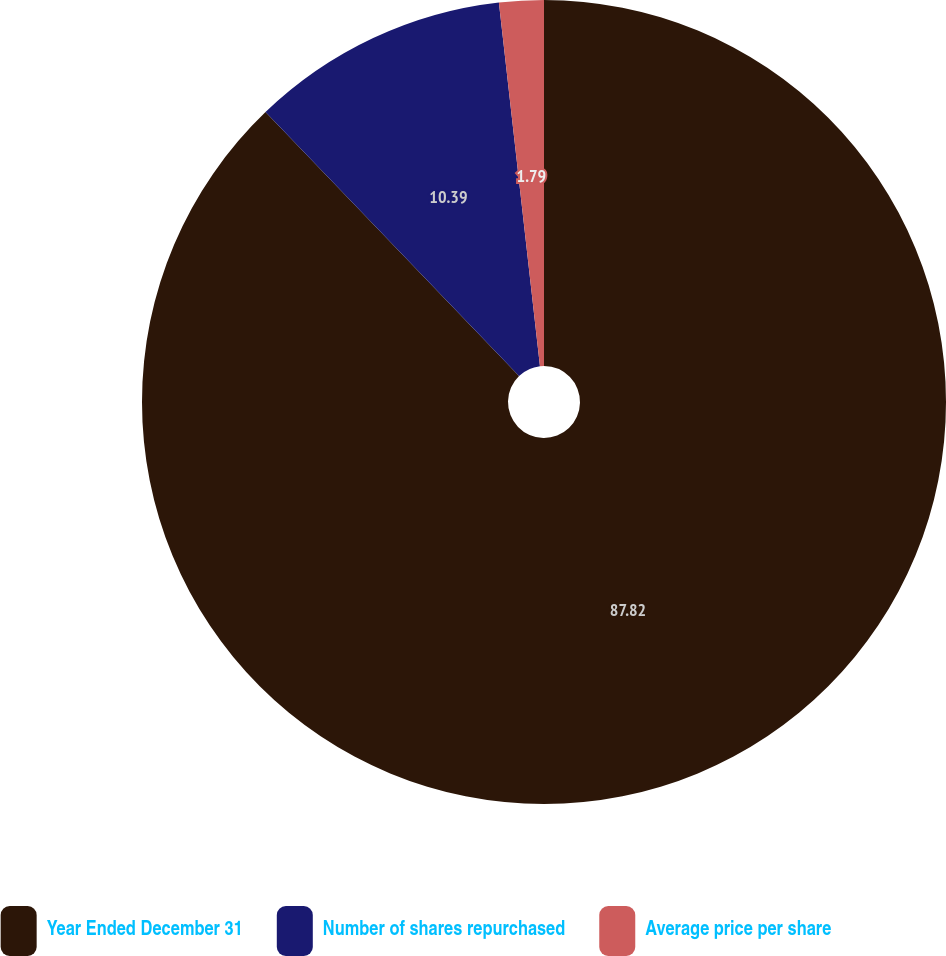Convert chart to OTSL. <chart><loc_0><loc_0><loc_500><loc_500><pie_chart><fcel>Year Ended December 31<fcel>Number of shares repurchased<fcel>Average price per share<nl><fcel>87.82%<fcel>10.39%<fcel>1.79%<nl></chart> 